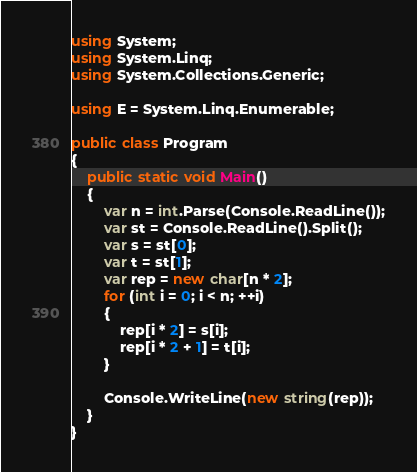Convert code to text. <code><loc_0><loc_0><loc_500><loc_500><_C#_>using System;
using System.Linq;
using System.Collections.Generic;

using E = System.Linq.Enumerable;

public class Program
{
    public static void Main()
    {
        var n = int.Parse(Console.ReadLine());
        var st = Console.ReadLine().Split();
        var s = st[0];
        var t = st[1];
        var rep = new char[n * 2];
        for (int i = 0; i < n; ++i)
        {
            rep[i * 2] = s[i];
            rep[i * 2 + 1] = t[i];
        }

        Console.WriteLine(new string(rep));
    }
}
</code> 